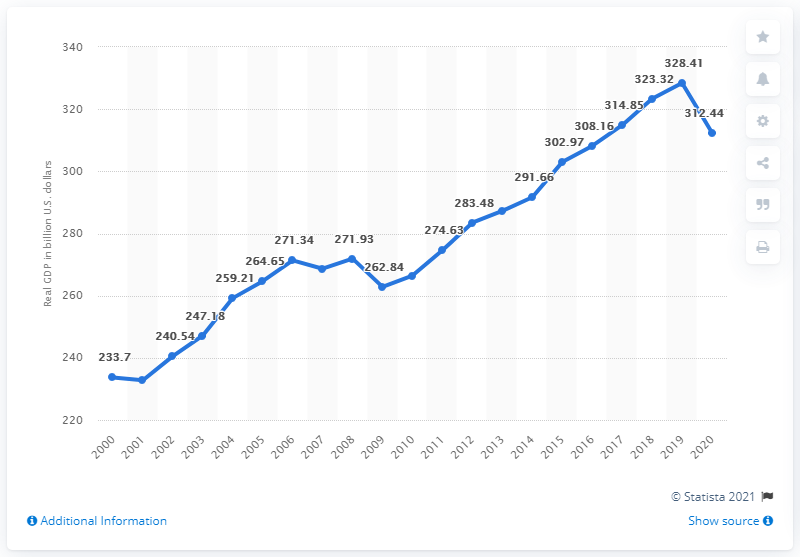Point out several critical features in this image. In 2020, the Gross Domestic Product (GDP) of the state of Tennessee was 312.44 billion dollars. In 2021, Tennessee's real GDP was $328.41 billion in current dollars. 